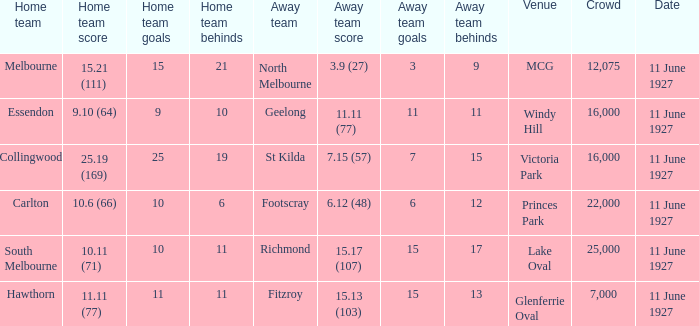How many people were in the crowd when Essendon was the home team? 1.0. 